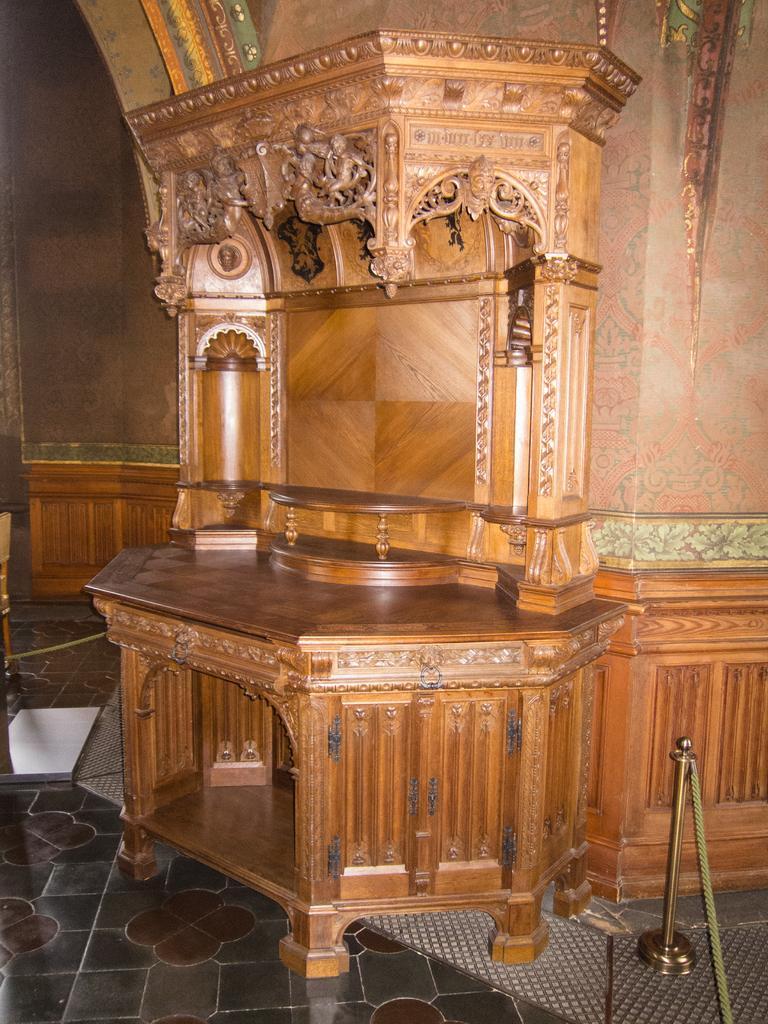Can you describe this image briefly? This is an inside view. Here I can see a table with some carvings. In the background there is a wall. At the bottom, I can see the floor. In the bottom right-hand corner there is a metal stand. 